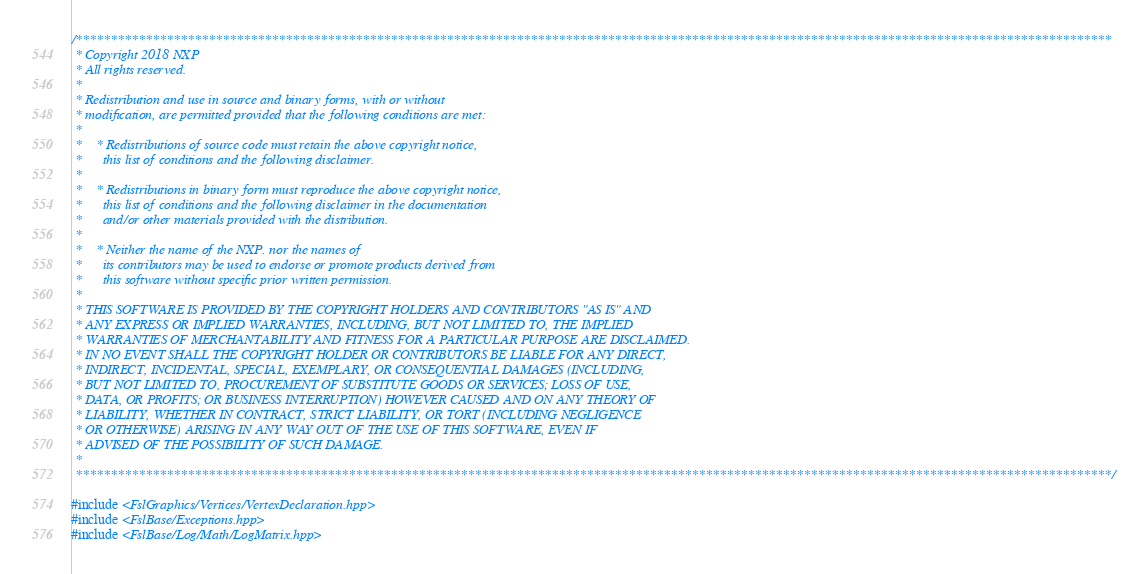<code> <loc_0><loc_0><loc_500><loc_500><_C++_>/****************************************************************************************************************************************************
 * Copyright 2018 NXP
 * All rights reserved.
 *
 * Redistribution and use in source and binary forms, with or without
 * modification, are permitted provided that the following conditions are met:
 *
 *    * Redistributions of source code must retain the above copyright notice,
 *      this list of conditions and the following disclaimer.
 *
 *    * Redistributions in binary form must reproduce the above copyright notice,
 *      this list of conditions and the following disclaimer in the documentation
 *      and/or other materials provided with the distribution.
 *
 *    * Neither the name of the NXP. nor the names of
 *      its contributors may be used to endorse or promote products derived from
 *      this software without specific prior written permission.
 *
 * THIS SOFTWARE IS PROVIDED BY THE COPYRIGHT HOLDERS AND CONTRIBUTORS "AS IS" AND
 * ANY EXPRESS OR IMPLIED WARRANTIES, INCLUDING, BUT NOT LIMITED TO, THE IMPLIED
 * WARRANTIES OF MERCHANTABILITY AND FITNESS FOR A PARTICULAR PURPOSE ARE DISCLAIMED.
 * IN NO EVENT SHALL THE COPYRIGHT HOLDER OR CONTRIBUTORS BE LIABLE FOR ANY DIRECT,
 * INDIRECT, INCIDENTAL, SPECIAL, EXEMPLARY, OR CONSEQUENTIAL DAMAGES (INCLUDING,
 * BUT NOT LIMITED TO, PROCUREMENT OF SUBSTITUTE GOODS OR SERVICES; LOSS OF USE,
 * DATA, OR PROFITS; OR BUSINESS INTERRUPTION) HOWEVER CAUSED AND ON ANY THEORY OF
 * LIABILITY, WHETHER IN CONTRACT, STRICT LIABILITY, OR TORT (INCLUDING NEGLIGENCE
 * OR OTHERWISE) ARISING IN ANY WAY OUT OF THE USE OF THIS SOFTWARE, EVEN IF
 * ADVISED OF THE POSSIBILITY OF SUCH DAMAGE.
 *
 ****************************************************************************************************************************************************/

#include <FslGraphics/Vertices/VertexDeclaration.hpp>
#include <FslBase/Exceptions.hpp>
#include <FslBase/Log/Math/LogMatrix.hpp></code> 